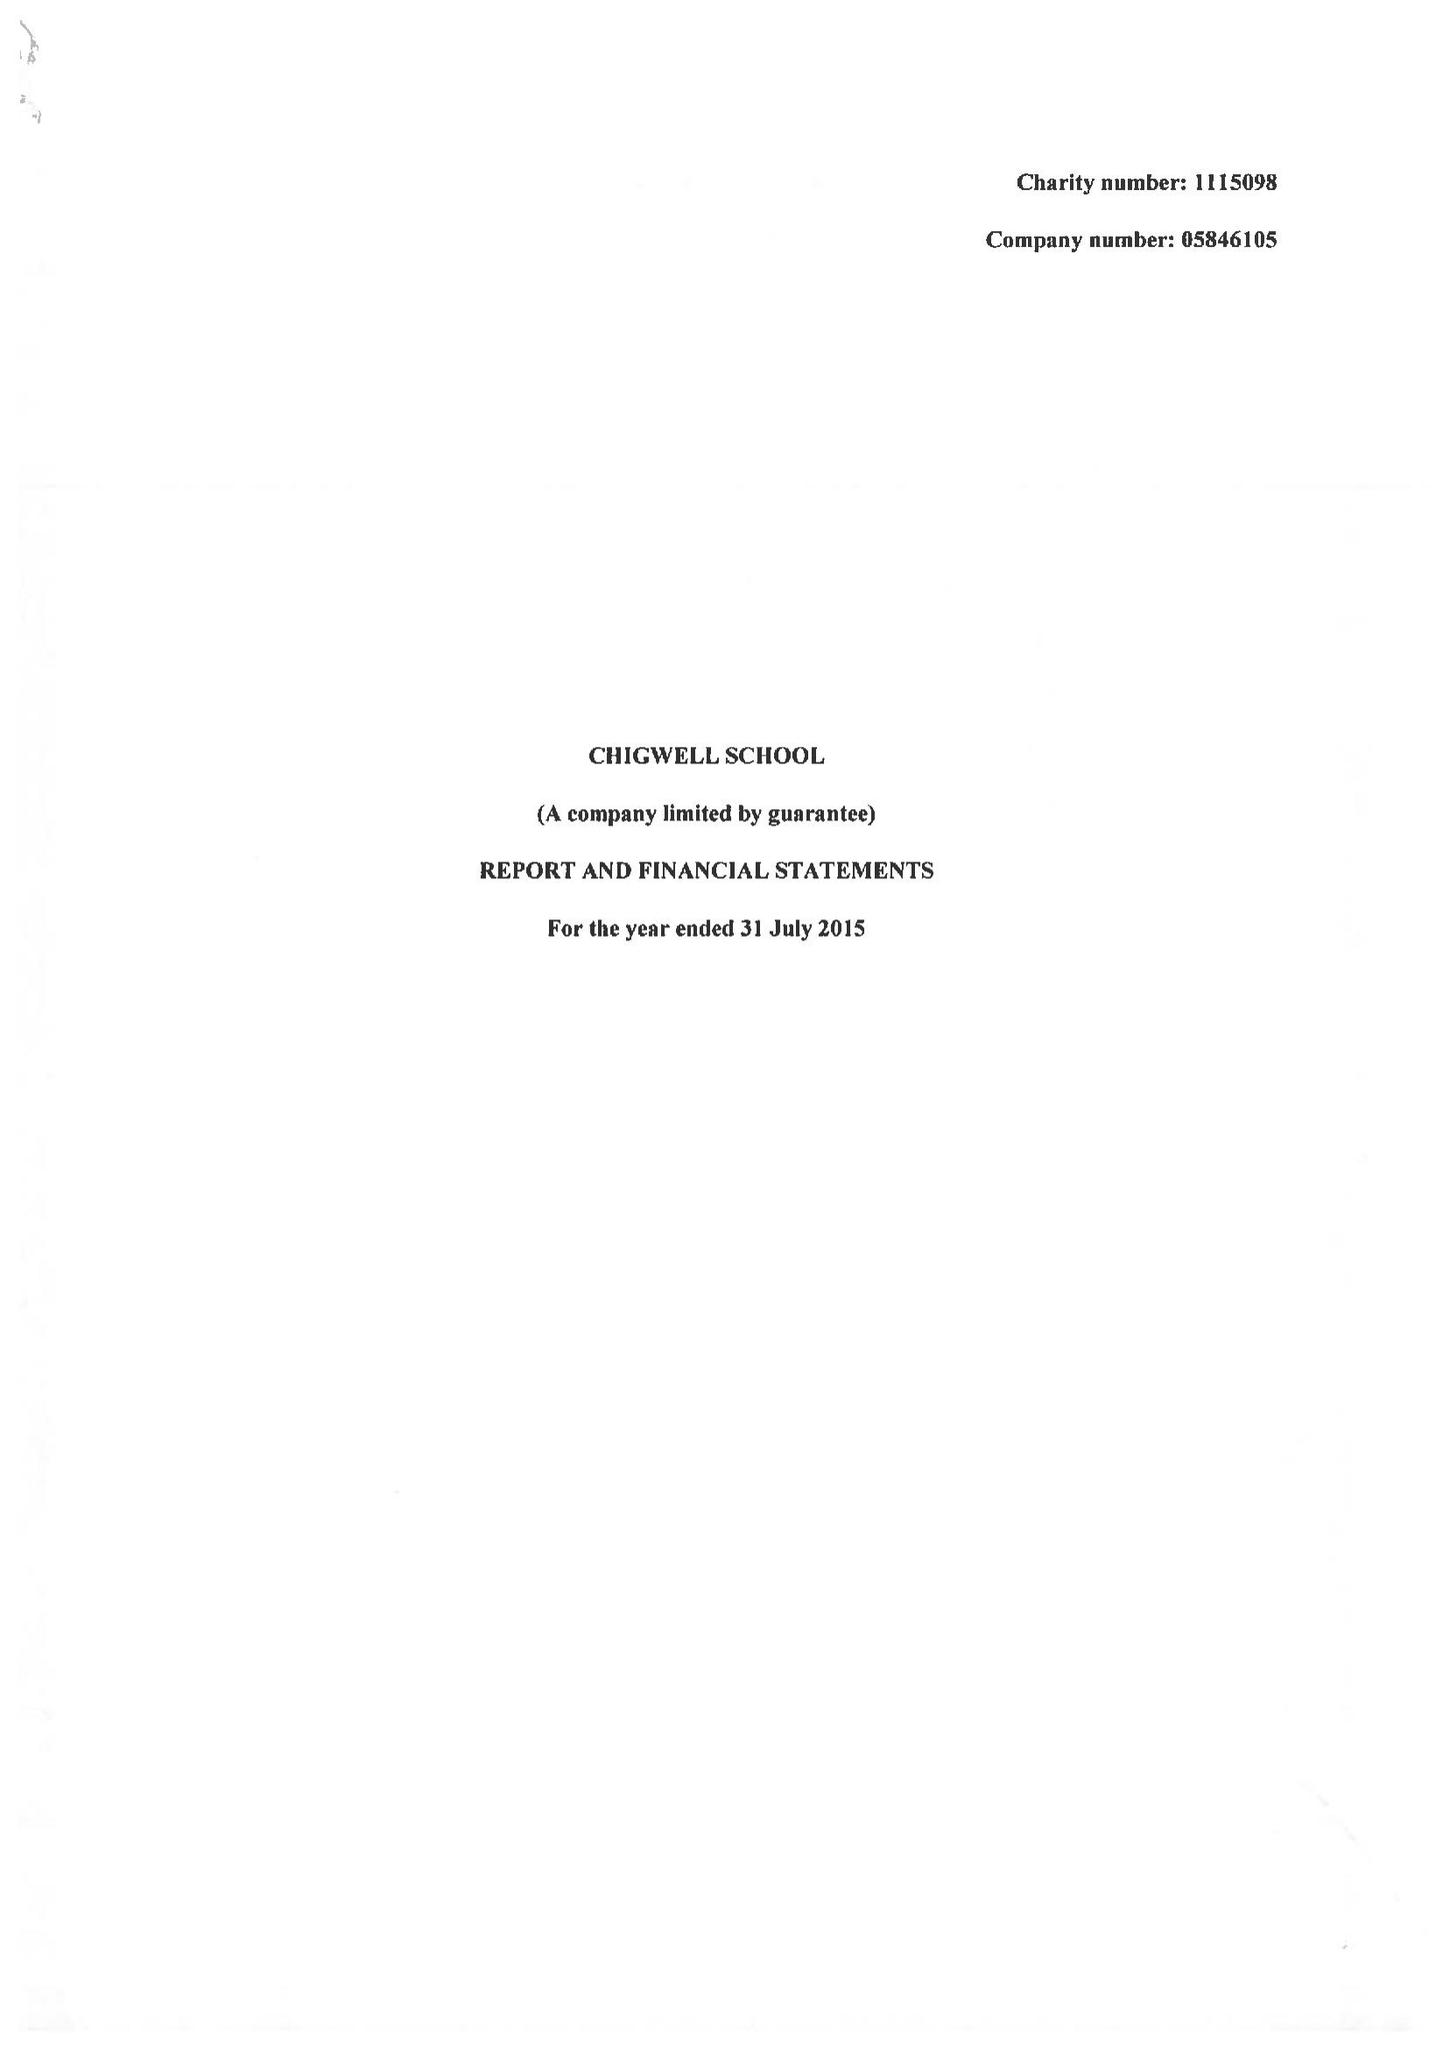What is the value for the address__postcode?
Answer the question using a single word or phrase. IG7 6QF 